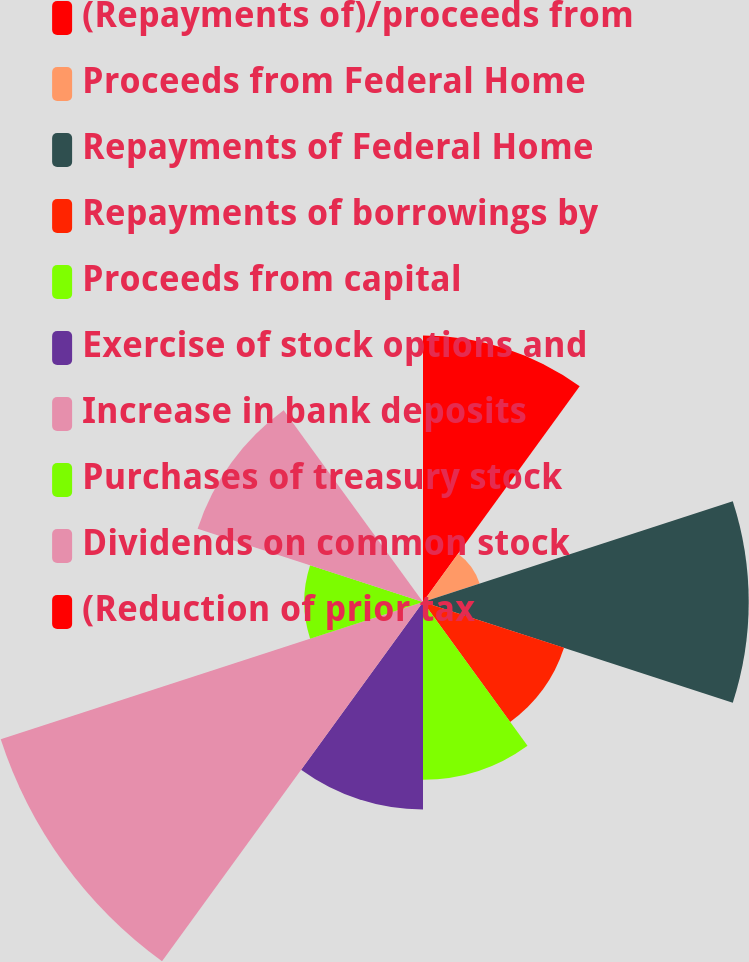Convert chart. <chart><loc_0><loc_0><loc_500><loc_500><pie_chart><fcel>(Repayments of)/proceeds from<fcel>Proceeds from Federal Home<fcel>Repayments of Federal Home<fcel>Repayments of borrowings by<fcel>Proceeds from capital<fcel>Exercise of stock options and<fcel>Increase in bank deposits<fcel>Purchases of treasury stock<fcel>Dividends on common stock<fcel>(Reduction of prior tax<nl><fcel>13.43%<fcel>3.0%<fcel>16.41%<fcel>7.47%<fcel>8.96%<fcel>10.45%<fcel>22.37%<fcel>5.98%<fcel>11.94%<fcel>0.01%<nl></chart> 